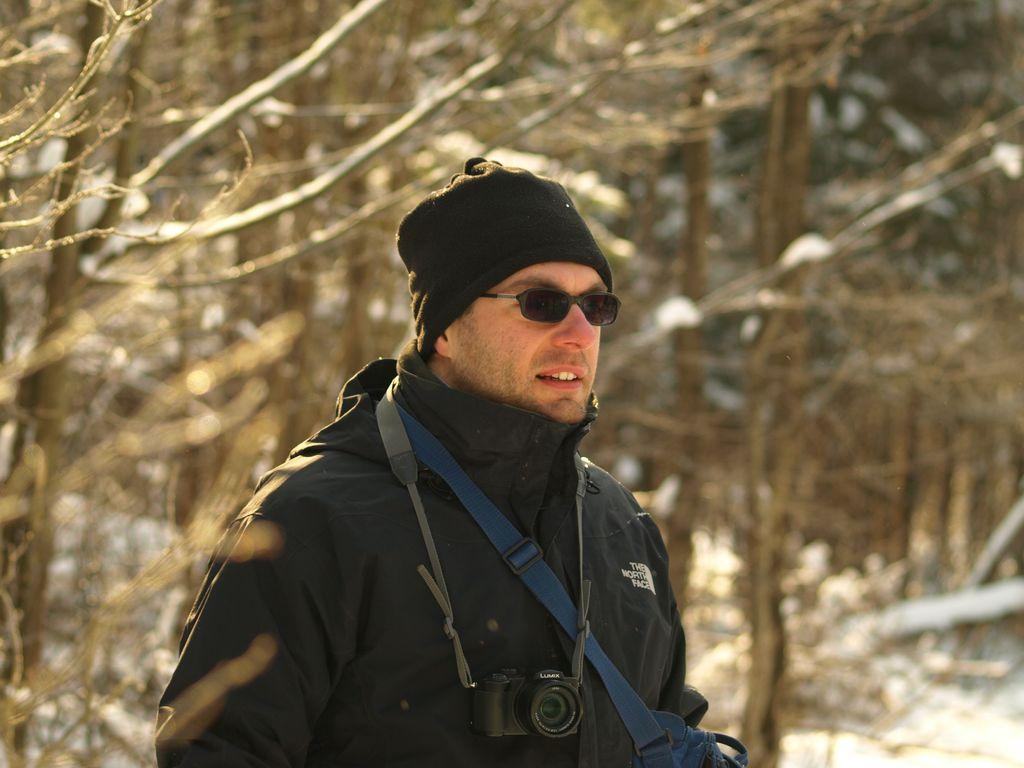Who is present in the image? There is a person in the image. What is the person wearing on their head? The person is wearing a cap. What type of accessory is the person carrying? The person has a bag across their shoulder. What object can be seen in the image that is typically used for capturing images? There is a camera in the image. What type of vegetation can be seen in the background of the image? There are dried trees in the background of the image. What type of cherry is being used to spread jam on the person's face in the image? There is no cherry or jam present in the image; the person is simply wearing a cap and carrying a bag. 